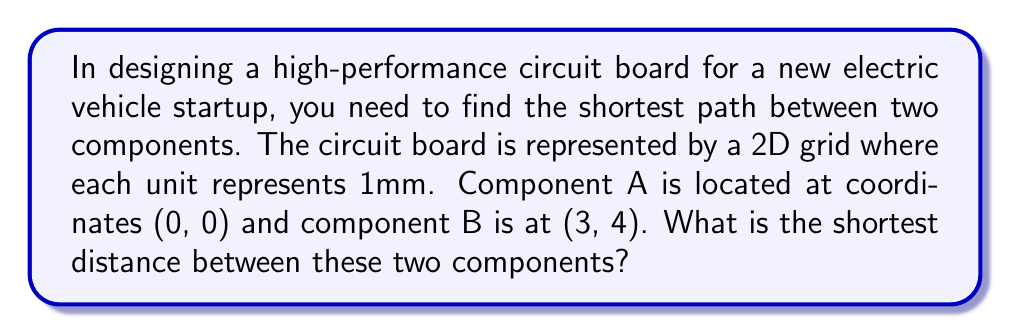Can you solve this math problem? Let's approach this step-by-step:

1) This problem can be solved using the distance formula, which is derived from the Pythagorean theorem. In a 2D plane, the distance between two points $(x_1, y_1)$ and $(x_2, y_2)$ is given by:

   $$d = \sqrt{(x_2 - x_1)^2 + (y_2 - y_1)^2}$$

2) In our case:
   - Point A: $(x_1, y_1) = (0, 0)$
   - Point B: $(x_2, y_2) = (3, 4)$

3) Let's substitute these values into the formula:

   $$d = \sqrt{(3 - 0)^2 + (4 - 0)^2}$$

4) Simplify:
   $$d = \sqrt{3^2 + 4^2}$$

5) Calculate:
   $$d = \sqrt{9 + 16} = \sqrt{25} = 5$$

6) Therefore, the shortest distance between the two components is 5 units on the grid, which represents 5mm on the actual circuit board.

[asy]
unitsize(1cm);
draw((-0.5,-0.5)--(3.5,4.5),gray);
draw((-0.5,-0.5)--(3.5,-0.5)--(3.5,4.5)--(-0.5,4.5)--cycle);
for(int i=0; i<=3; ++i) {
  for(int j=0; j<=4; ++j) {
    dot((i,j),gray);
  }
}
dot((0,0),red);
dot((3,4),red);
draw((0,0)--(3,4),red);
label("A",(0,0),SW);
label("B",(3,4),NE);
label("5mm",(1.5,2),SE);
[/asy]
Answer: 5mm 